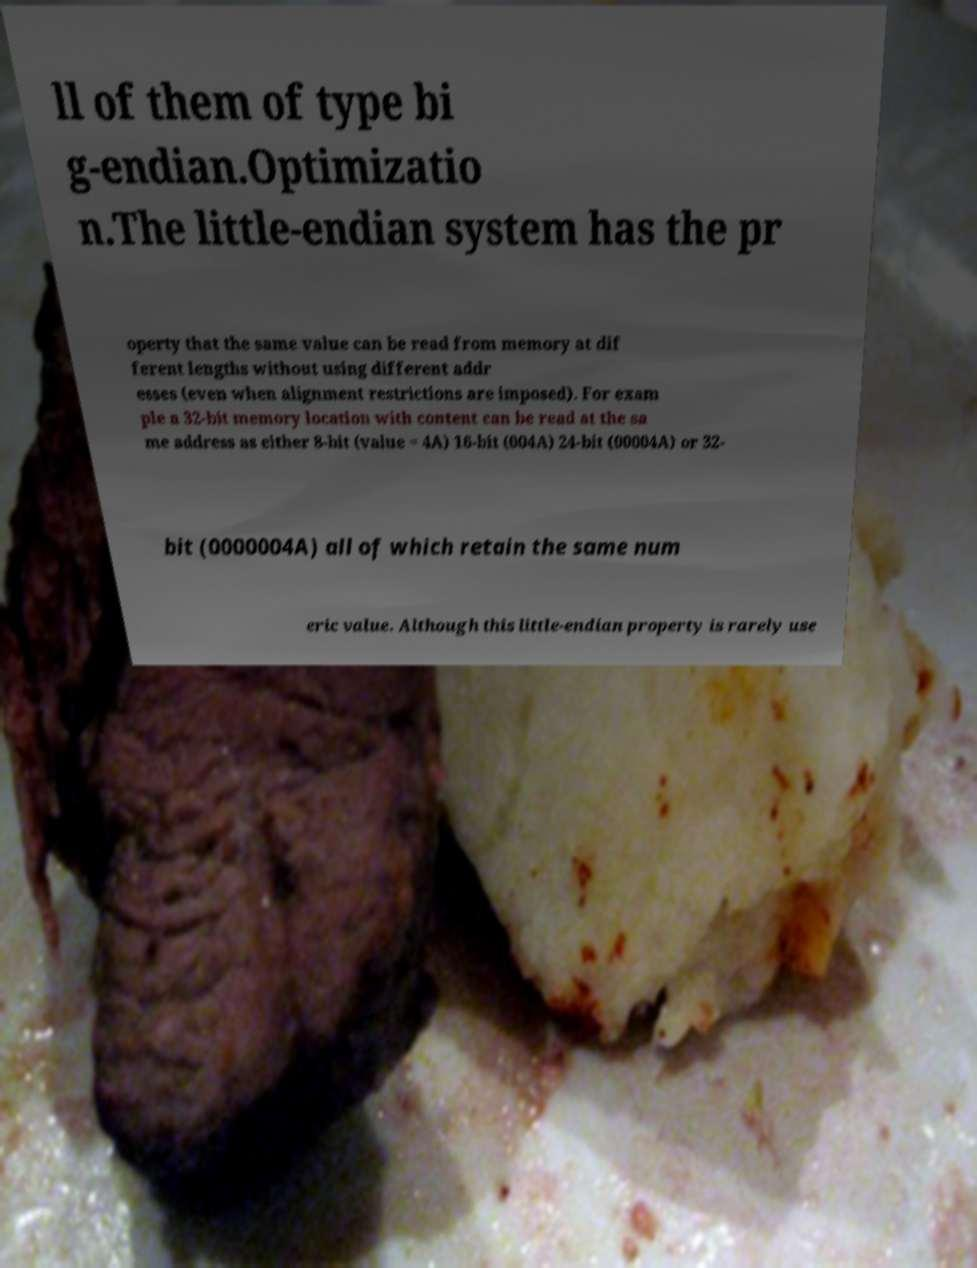Can you accurately transcribe the text from the provided image for me? ll of them of type bi g-endian.Optimizatio n.The little-endian system has the pr operty that the same value can be read from memory at dif ferent lengths without using different addr esses (even when alignment restrictions are imposed). For exam ple a 32-bit memory location with content can be read at the sa me address as either 8-bit (value = 4A) 16-bit (004A) 24-bit (00004A) or 32- bit (0000004A) all of which retain the same num eric value. Although this little-endian property is rarely use 